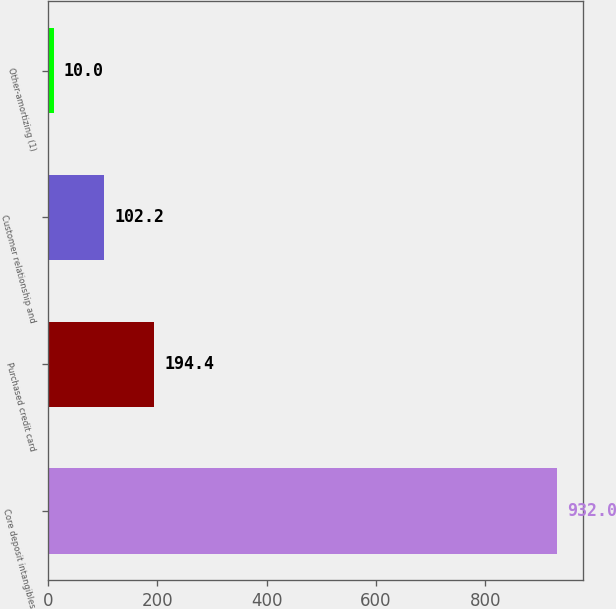<chart> <loc_0><loc_0><loc_500><loc_500><bar_chart><fcel>Core deposit intangibles<fcel>Purchased credit card<fcel>Customer relationship and<fcel>Other-amortizing (1)<nl><fcel>932<fcel>194.4<fcel>102.2<fcel>10<nl></chart> 